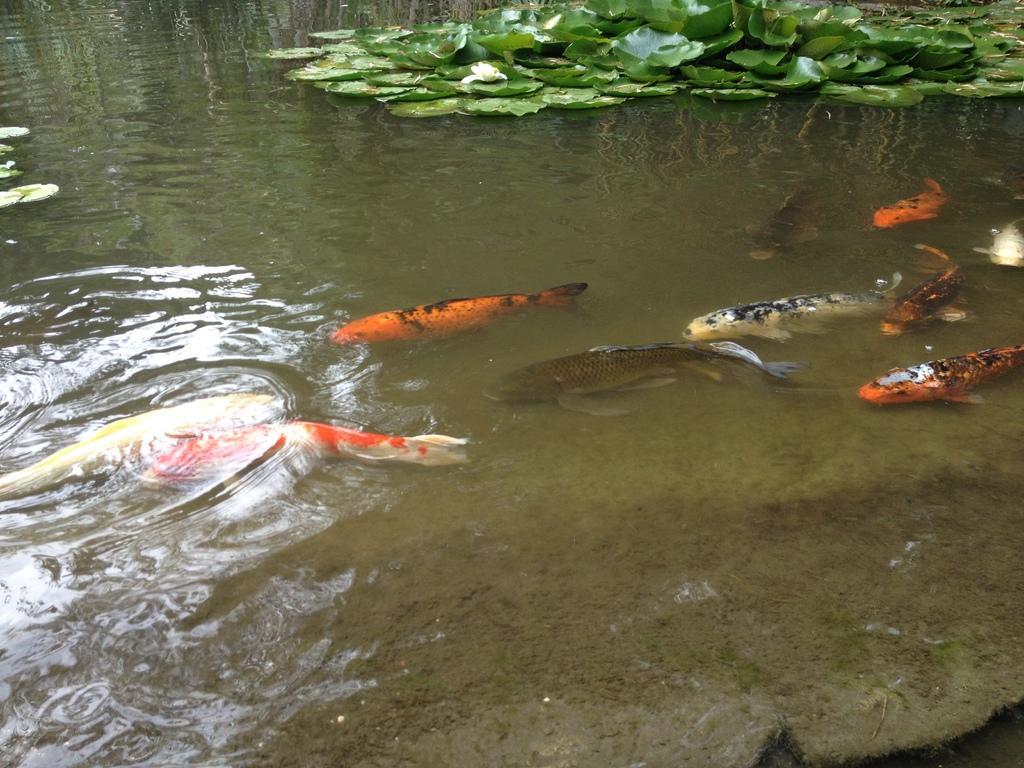Can you describe this image briefly? In this image we can see some fishes in the water. We can also see some plants floating on the water. 